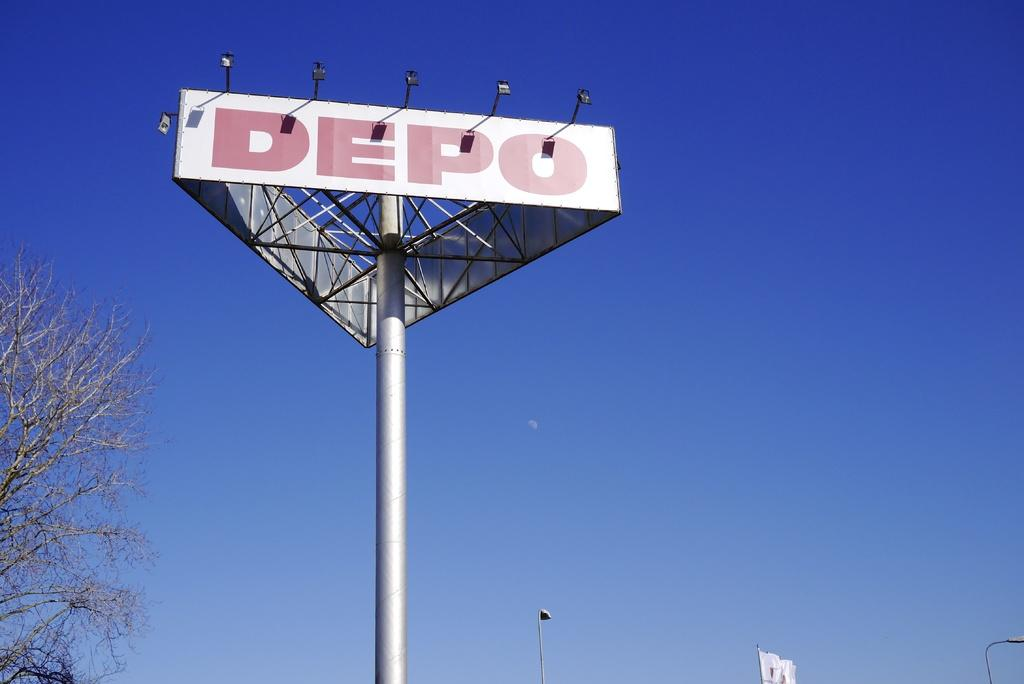<image>
Present a compact description of the photo's key features. A large billboard with the word DEPO printed across it. 